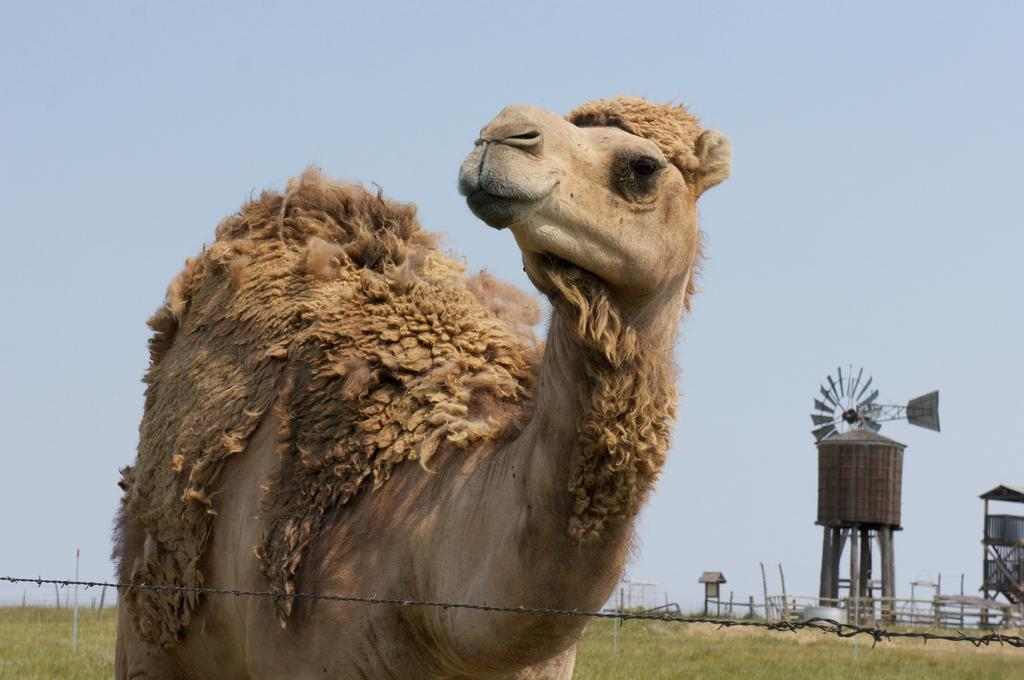What is the main subject in the center of the image? There is a camel in the center of the image. What can be seen in the background of the image? There is a windmill, poles, wires, and a shed in the background of the image. What is visible at the top of the image? The sky is visible at the top of the image. What type of brush is being used to paint the hill in the image? There is no hill or brush present in the image. What flavor of pie is being served on the table in the image? There is no pie or table present in the image. 